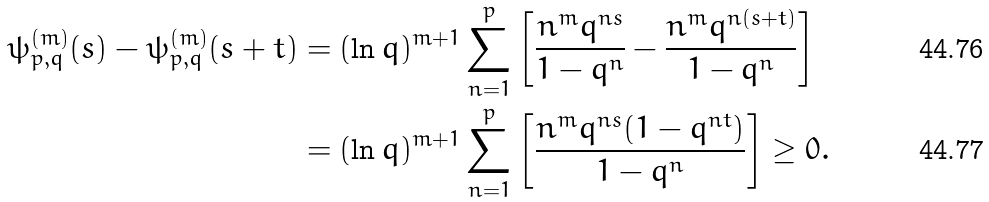<formula> <loc_0><loc_0><loc_500><loc_500>\psi _ { p , q } ^ { ( m ) } ( s ) - \psi _ { p , q } ^ { ( m ) } ( s + t ) & = ( \ln q ) ^ { m + 1 } \sum _ { n = 1 } ^ { p } \left [ \frac { n ^ { m } q ^ { n s } } { 1 - q ^ { n } } - \frac { n ^ { m } q ^ { n ( s + t ) } } { 1 - q ^ { n } } \right ] \\ & = ( \ln q ) ^ { m + 1 } \sum _ { n = 1 } ^ { p } \left [ \frac { n ^ { m } q ^ { n s } ( 1 - q ^ { n t } ) } { 1 - q ^ { n } } \right ] \geq 0 . \,</formula> 